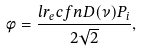Convert formula to latex. <formula><loc_0><loc_0><loc_500><loc_500>\phi = \frac { l r _ { e } c f n D ( \nu ) P _ { i } } { 2 \sqrt { 2 } } ,</formula> 